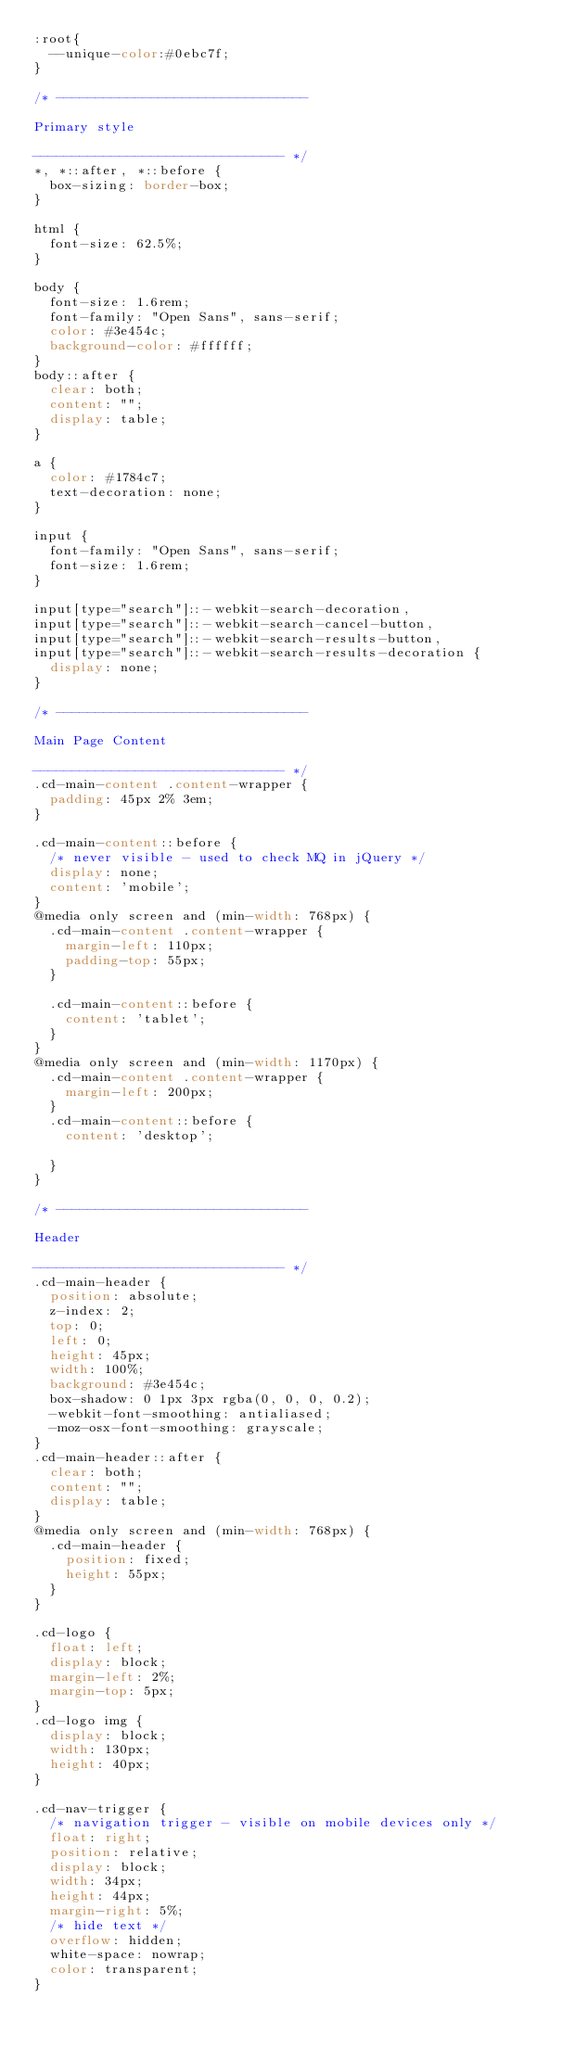Convert code to text. <code><loc_0><loc_0><loc_500><loc_500><_CSS_>:root{
  --unique-color:#0ebc7f;
}

/* -------------------------------- 

Primary style

-------------------------------- */
*, *::after, *::before {
  box-sizing: border-box;
}

html {
  font-size: 62.5%;
}

body {
  font-size: 1.6rem;
  font-family: "Open Sans", sans-serif;
  color: #3e454c;
  background-color: #ffffff;
}
body::after {
  clear: both;
  content: "";
  display: table;
}

a {
  color: #1784c7;
  text-decoration: none;
}

input {
  font-family: "Open Sans", sans-serif;
  font-size: 1.6rem;
}

input[type="search"]::-webkit-search-decoration,
input[type="search"]::-webkit-search-cancel-button,
input[type="search"]::-webkit-search-results-button,
input[type="search"]::-webkit-search-results-decoration {
  display: none;
}

/* -------------------------------- 

Main Page Content

-------------------------------- */
.cd-main-content .content-wrapper {
  padding: 45px 2% 3em;
}

.cd-main-content::before {
  /* never visible - used to check MQ in jQuery */
  display: none;
  content: 'mobile';
}
@media only screen and (min-width: 768px) {
  .cd-main-content .content-wrapper {
    margin-left: 110px;
    padding-top: 55px;
  }
  
  .cd-main-content::before {
    content: 'tablet';
  }
}
@media only screen and (min-width: 1170px) {
  .cd-main-content .content-wrapper {
    margin-left: 200px;
  }
  .cd-main-content::before {
    content: 'desktop';

  }
}

/* -------------------------------- 

Header

-------------------------------- */
.cd-main-header {
  position: absolute;
  z-index: 2;
  top: 0;
  left: 0;
  height: 45px;
  width: 100%;
  background: #3e454c;
  box-shadow: 0 1px 3px rgba(0, 0, 0, 0.2);
  -webkit-font-smoothing: antialiased;
  -moz-osx-font-smoothing: grayscale;
}
.cd-main-header::after {
  clear: both;
  content: "";
  display: table;
}
@media only screen and (min-width: 768px) {
  .cd-main-header {
    position: fixed;
    height: 55px;
  }
}

.cd-logo {
  float: left;
  display: block;
  margin-left: 2%;
  margin-top: 5px;
}
.cd-logo img {
  display: block;
  width: 130px;
  height: 40px;
}

.cd-nav-trigger {
  /* navigation trigger - visible on mobile devices only */
  float: right;
  position: relative;
  display: block;
  width: 34px;
  height: 44px;
  margin-right: 5%;
  /* hide text */
  overflow: hidden;
  white-space: nowrap;
  color: transparent;
}</code> 